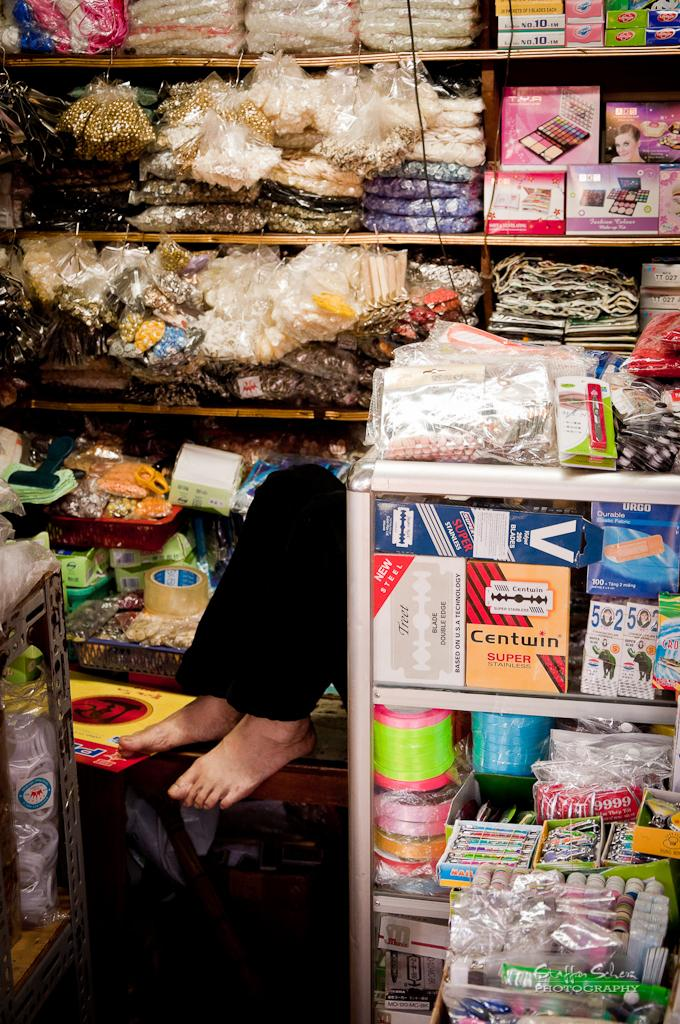<image>
Render a clear and concise summary of the photo. Store selling many items including one named "Centwin". 